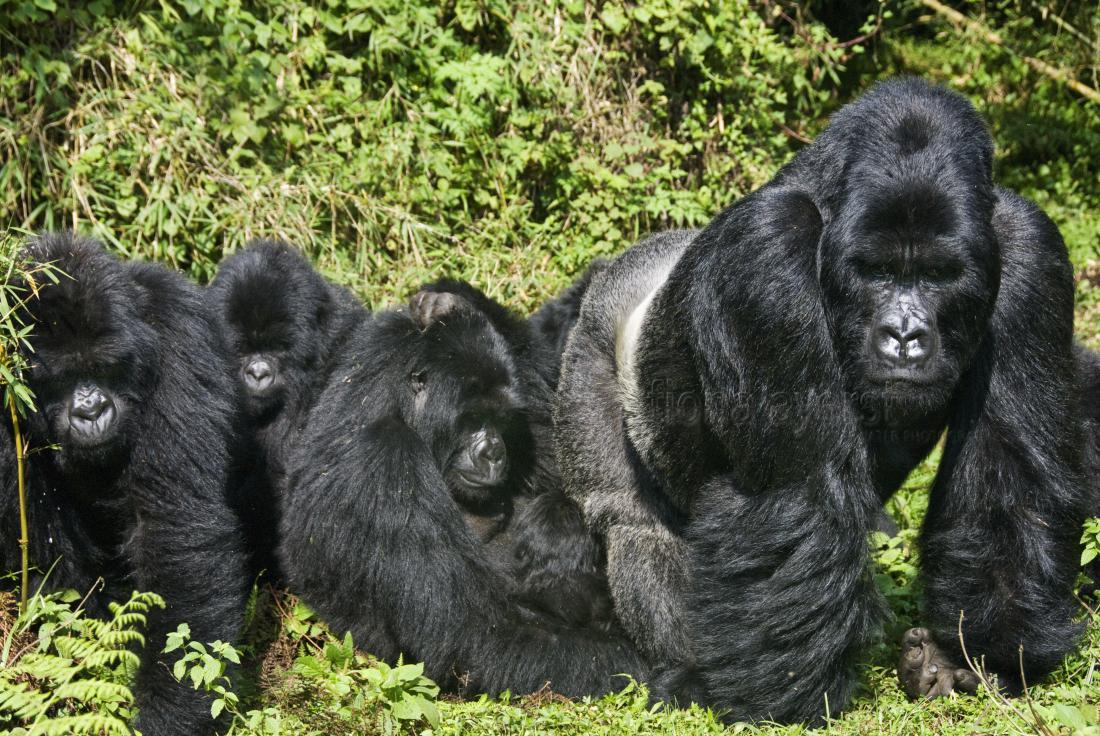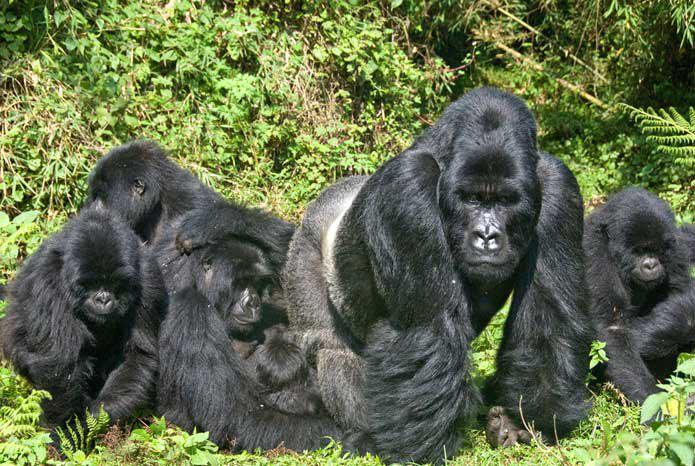The first image is the image on the left, the second image is the image on the right. For the images displayed, is the sentence "All of the images have two generations of apes." factually correct? Answer yes or no. Yes. The first image is the image on the left, the second image is the image on the right. Considering the images on both sides, is "The small gorilla is on top of the larger one in the image on the left." valid? Answer yes or no. No. 